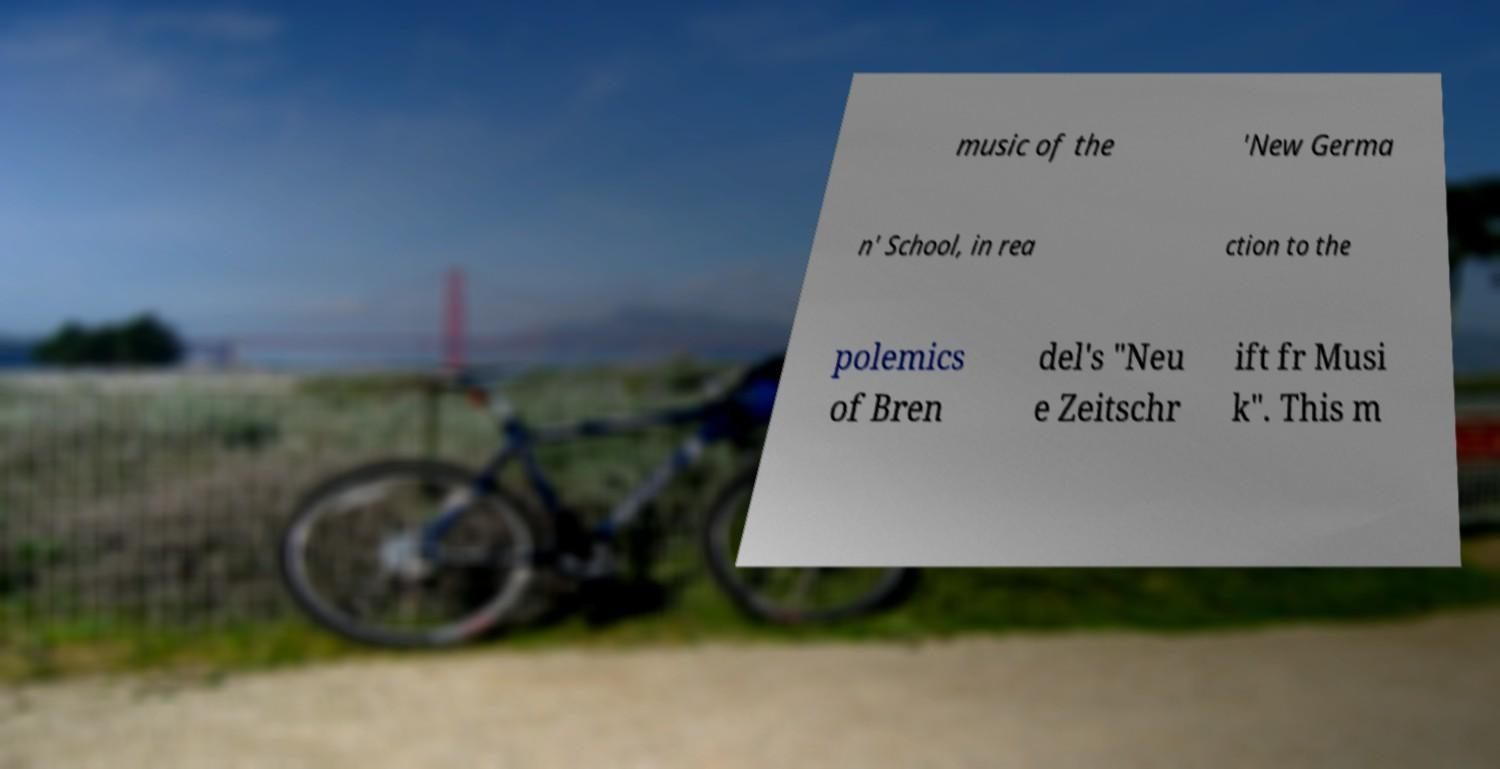For documentation purposes, I need the text within this image transcribed. Could you provide that? music of the 'New Germa n' School, in rea ction to the polemics of Bren del's "Neu e Zeitschr ift fr Musi k". This m 